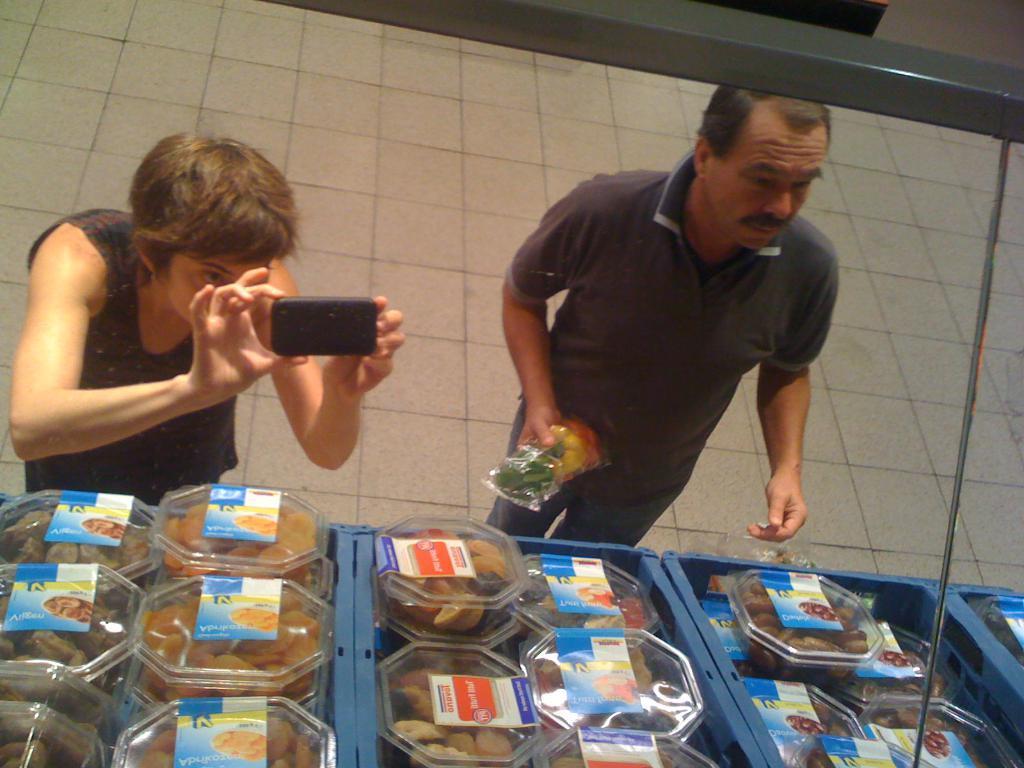In one or two sentences, can you explain what this image depicts? In this picture we can see people standing near to a stall. In the background there is a floor. We can see a person holding a mobile with the hands and taking a snap. At the bottom portion of the picture we can see food packed in the transparent boxes. 